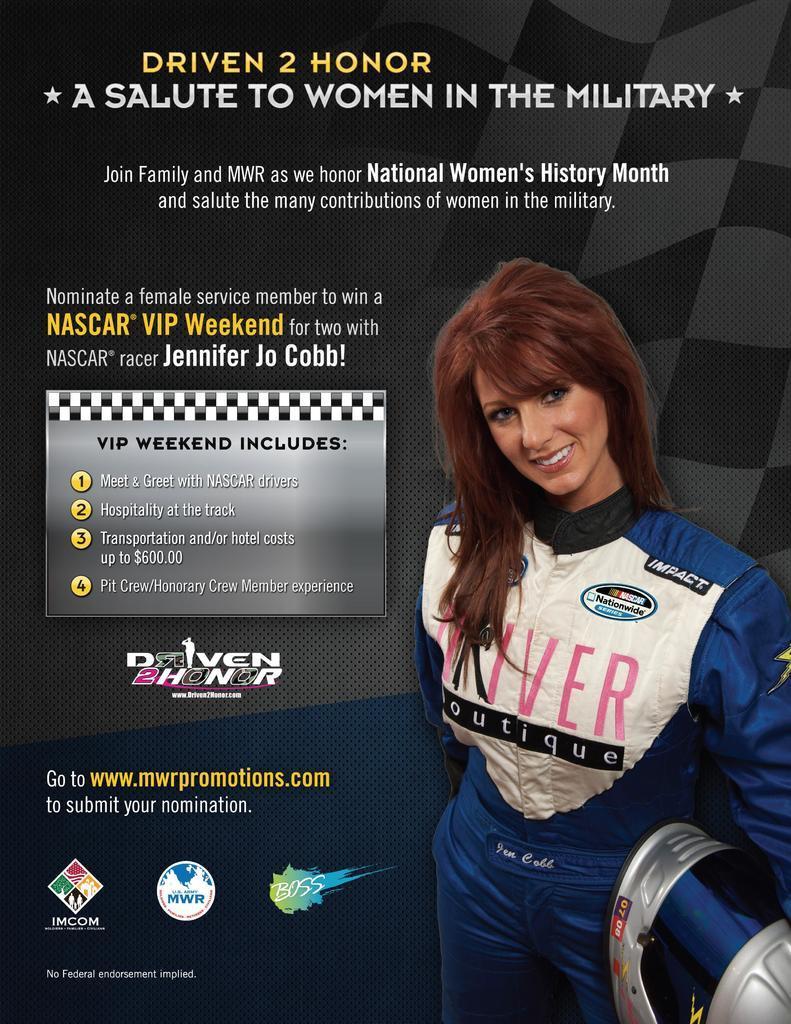How would you summarize this image in a sentence or two? This image looks like an edited photo, in which I can see a woman is holding an object in hand, text and logos. 